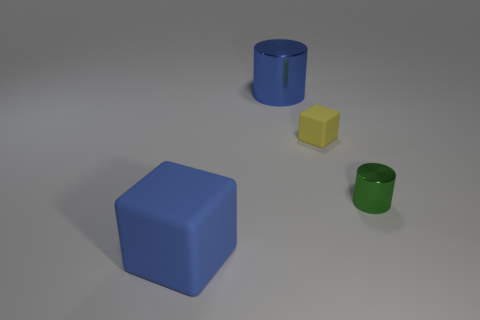How many other objects are the same shape as the large blue rubber object?
Offer a very short reply. 1. Are there any cylinders that are on the right side of the metallic object on the left side of the cube behind the tiny green metallic object?
Offer a very short reply. Yes. What number of large things are either blue cylinders or matte objects?
Offer a very short reply. 2. Are there any other things that are the same color as the big metal cylinder?
Your answer should be very brief. Yes. There is a cube that is behind the blue matte cube; is its size the same as the green metallic thing?
Offer a very short reply. Yes. There is a tiny metallic cylinder on the right side of the cube that is in front of the cube that is right of the large matte cube; what color is it?
Give a very brief answer. Green. The big shiny cylinder is what color?
Your response must be concise. Blue. Is the large cylinder the same color as the big matte block?
Your answer should be very brief. Yes. Do the blue object behind the tiny green shiny thing and the cylinder that is in front of the big blue shiny cylinder have the same material?
Offer a terse response. Yes. There is a tiny yellow object that is the same shape as the large blue rubber thing; what material is it?
Your answer should be very brief. Rubber. 